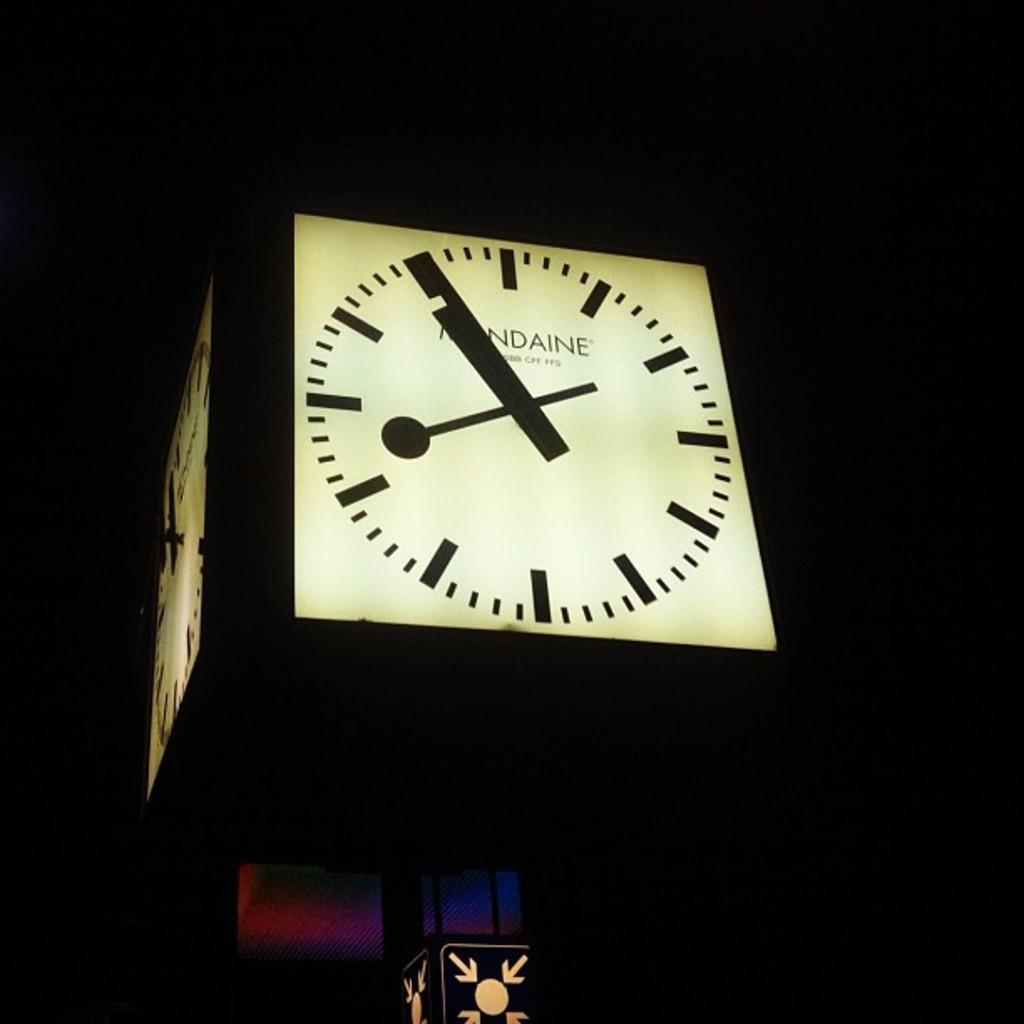<image>
Relay a brief, clear account of the picture shown. A lit-up clock face has a word that ends with "ndaine" on the face. 